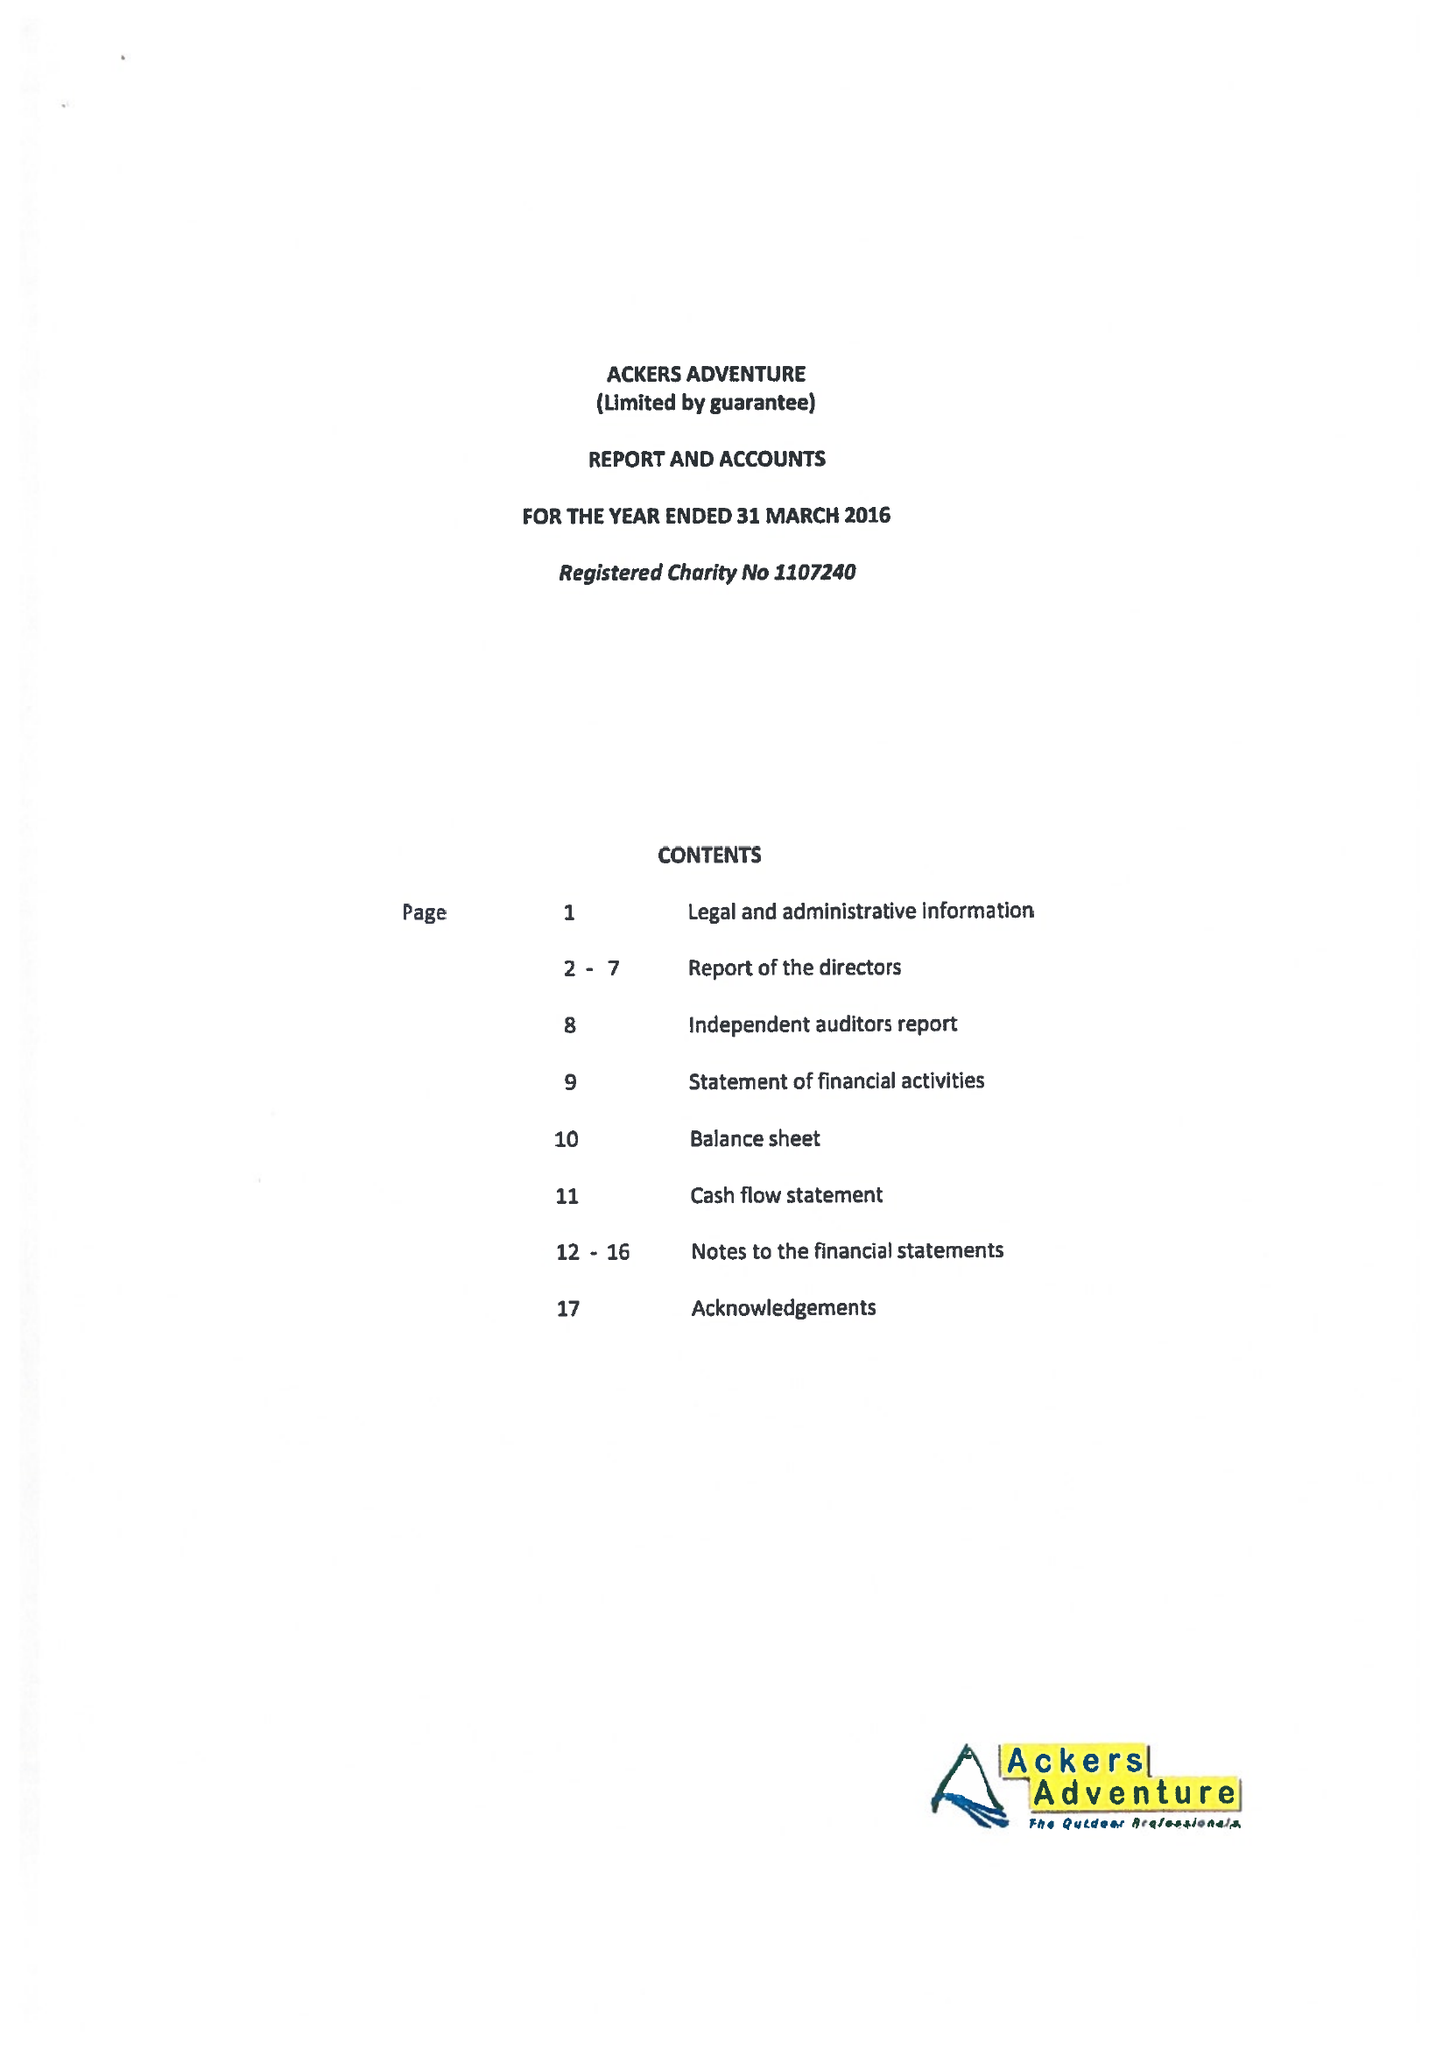What is the value for the spending_annually_in_british_pounds?
Answer the question using a single word or phrase. 437602.00 